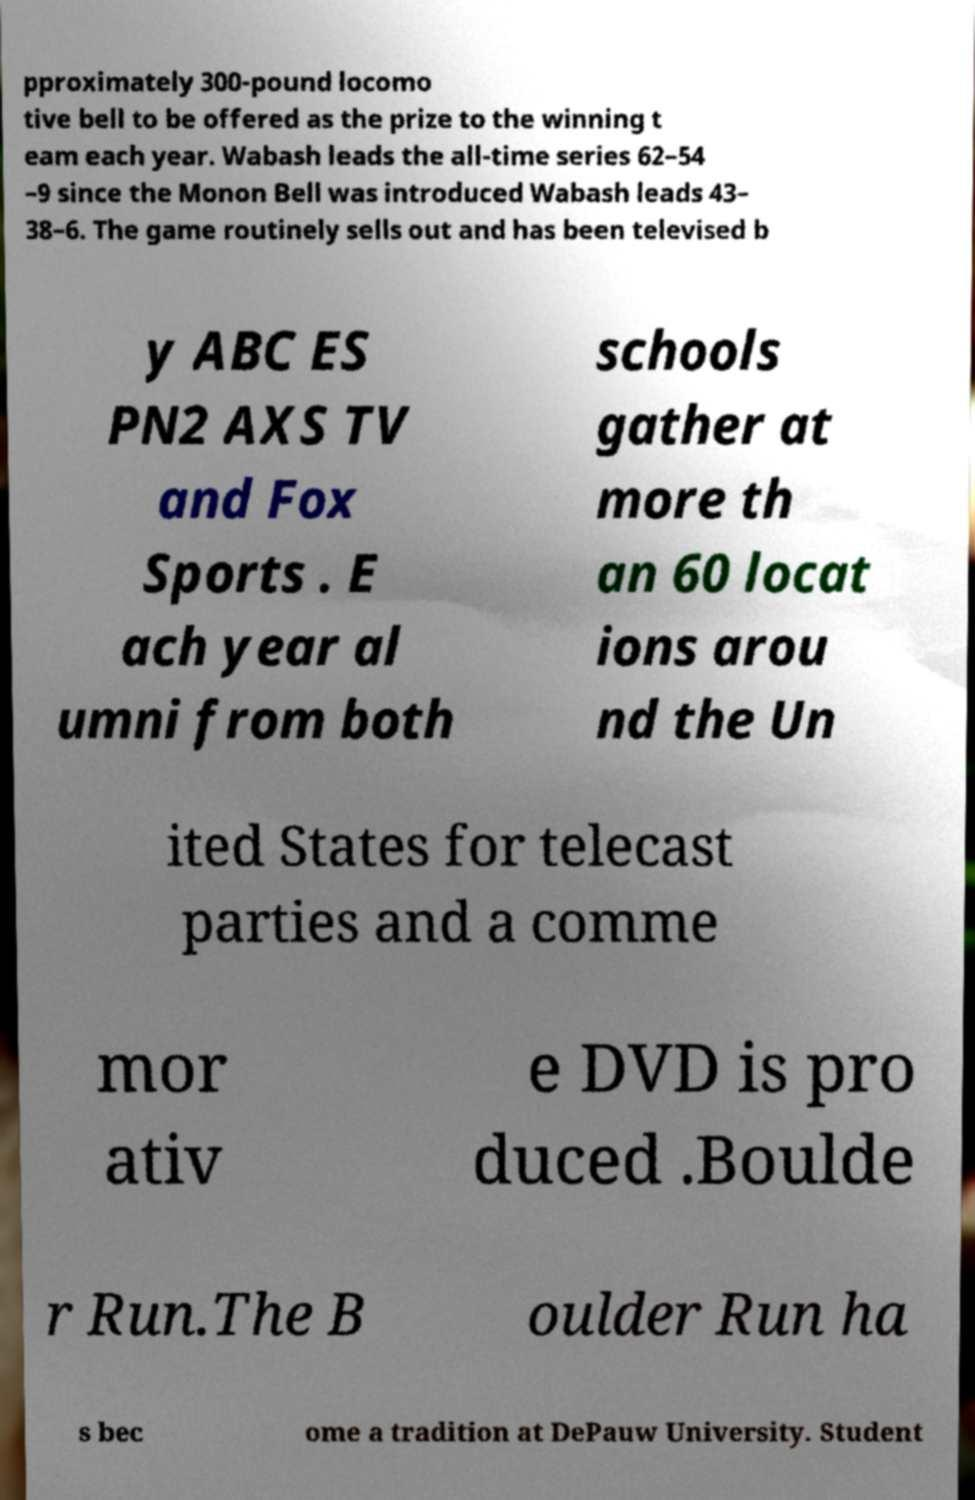Can you accurately transcribe the text from the provided image for me? pproximately 300-pound locomo tive bell to be offered as the prize to the winning t eam each year. Wabash leads the all-time series 62–54 –9 since the Monon Bell was introduced Wabash leads 43– 38–6. The game routinely sells out and has been televised b y ABC ES PN2 AXS TV and Fox Sports . E ach year al umni from both schools gather at more th an 60 locat ions arou nd the Un ited States for telecast parties and a comme mor ativ e DVD is pro duced .Boulde r Run.The B oulder Run ha s bec ome a tradition at DePauw University. Student 